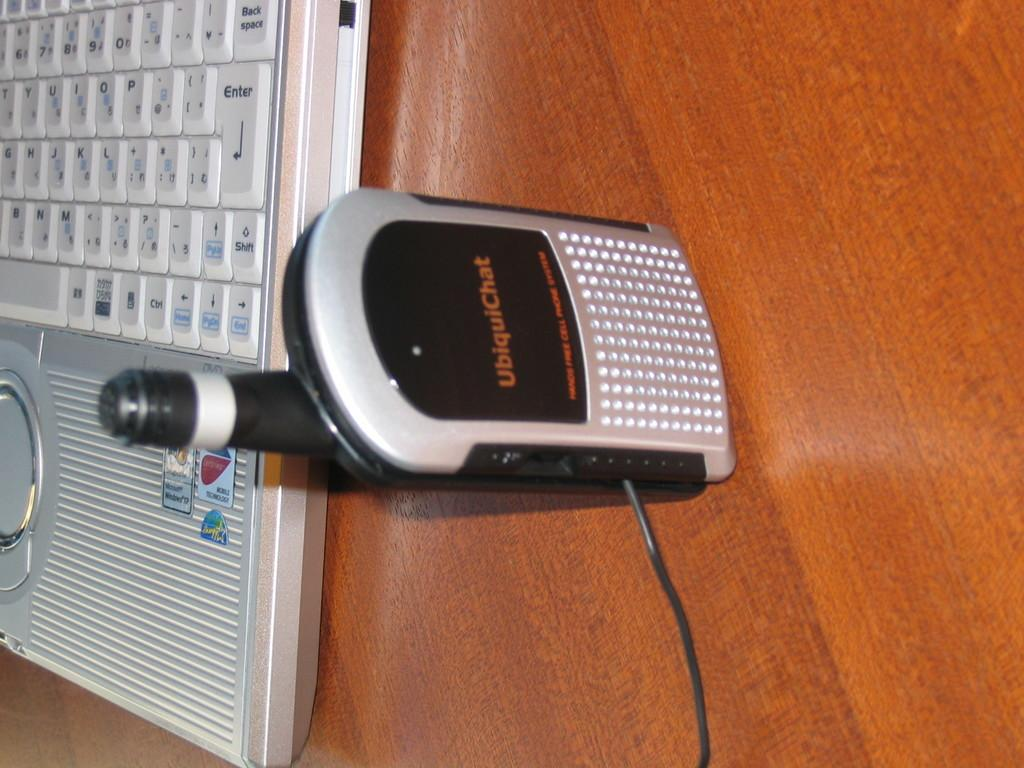What is the main object in the center of the image? There is a microphone in the center of the image. What other object can be seen in the image? There is a laptop keyboard in the image. Where are the microphone and laptop keyboard placed? The microphone and laptop keyboard are placed on a wooden table. What type of advice can be seen written on the shelf in the image? There is no shelf present in the image, and therefore no advice can be seen written on it. 